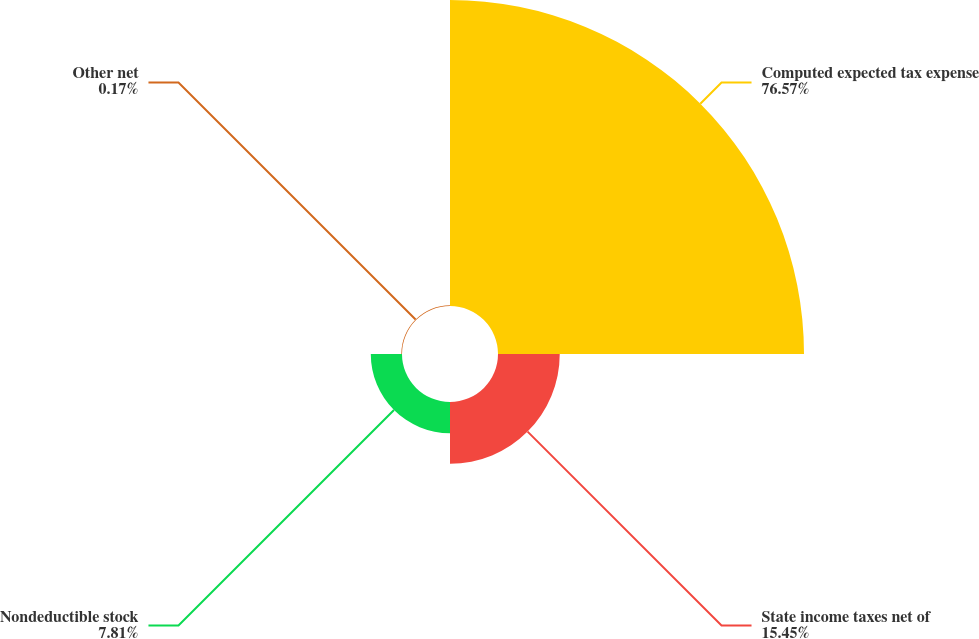Convert chart to OTSL. <chart><loc_0><loc_0><loc_500><loc_500><pie_chart><fcel>Computed expected tax expense<fcel>State income taxes net of<fcel>Nondeductible stock<fcel>Other net<nl><fcel>76.57%<fcel>15.45%<fcel>7.81%<fcel>0.17%<nl></chart> 